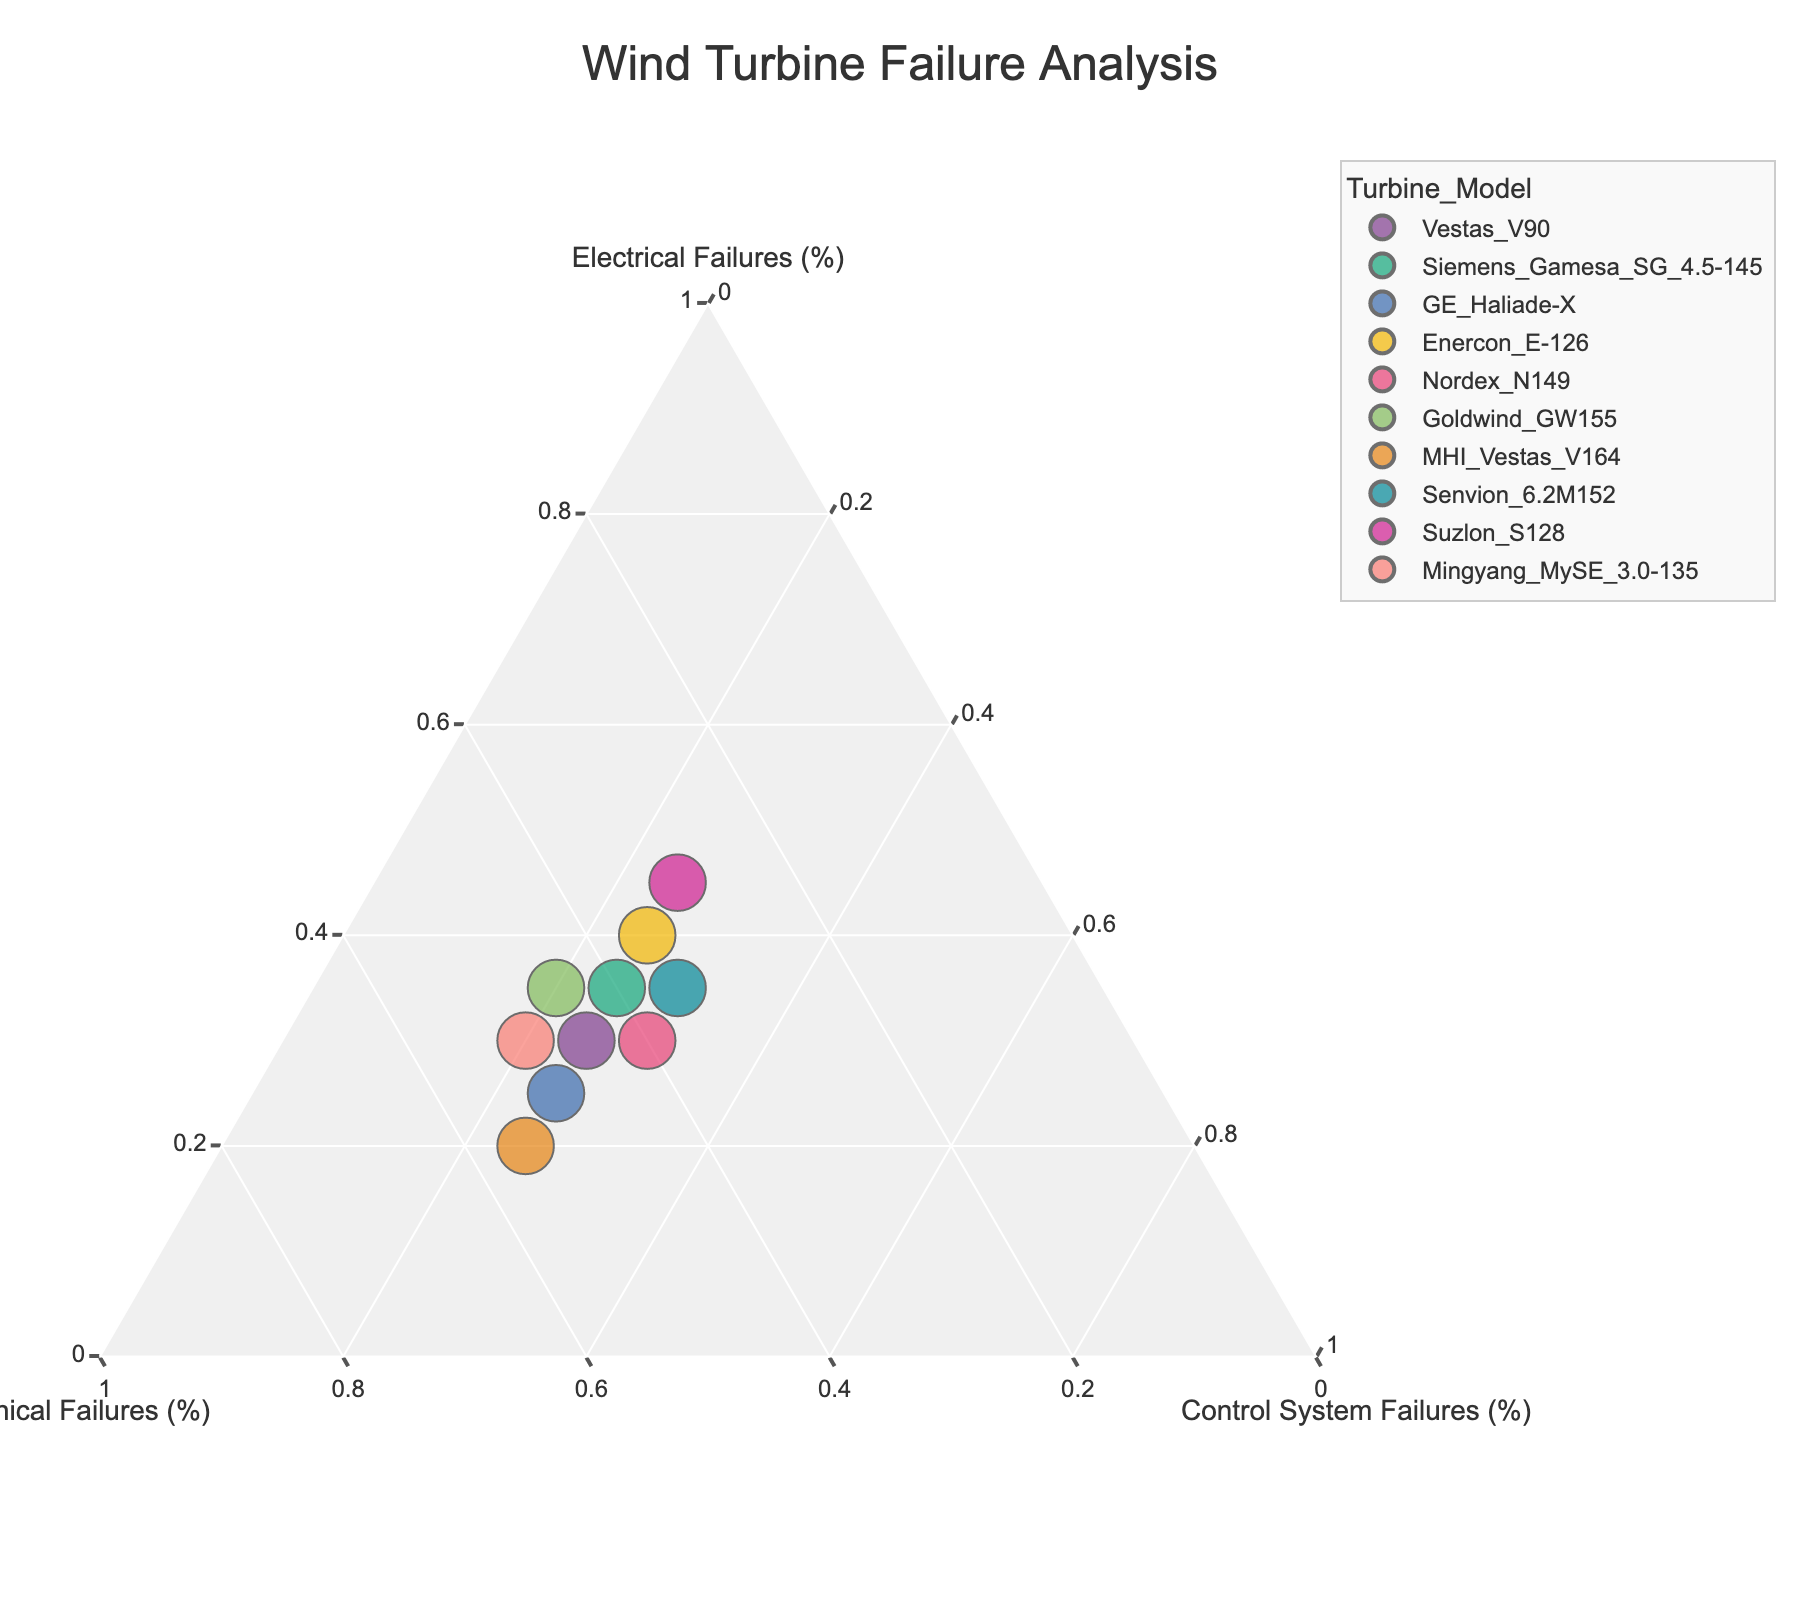What is the title of the chart? The title can be found at the top center of the figure. It is set to provide an overview of the content displayed in the plot.
Answer: Wind Turbine Failure Analysis How many turbine models are analyzed in the plot? The number of unique points representing different turbine models can be determined by counting the distinct markers on the ternary plot. Each marker corresponds to a different turbine model.
Answer: 10 Which turbine model has the highest percentage of electrical failures? By observing the ternary plot, locate the point that is closest to the Electrical Failures (%) axis (i.e., the bottom vertex). The corresponding turbine model will have the highest percentage of electrical failures.
Answer: Suzlon_S128 What is the distribution of failures for the GE Haliade-X turbine? Find the marker associated with the GE Haliade-X turbine and observe its position relative to the three axes. The percentages are given by its relative distance to the vertices for Electrical, Mechanical, and Control System Failures.
Answer: Electrical: 25%, Mechanical: 50%, Control System: 25% Which turbine model has an equal percentage of mechanical and electrical failures? Identify points that lie equidistant from the Mechanical and Electrical axes or fall on the line bisecting the angle between those axes. The hover information can confirm the exact model.
Answer: Senvion_6.2M152 What is the total percentage of failures for the Nordex N149 turbine? The total percentage can be found by adding the contributions from Electrical, Mechanical, and Control System Failures for the Nordex N149 turbine. Observe the relative distances from each axis for this marker.
Answer: 100% How does the failure composition of Vestas V90 compare to Enercon E-126? Locate the markers for both Vestas V90 and Enercon E-126. Compare their positions relative to the three axes, focusing on the proportional contribution of each failure type.
Answer: Vestas V90: Electrical: 30%, Mechanical: 45%, Control System: 25%; Enercon E-126: Electrical: 40%, Mechanical: 35%, Control System: 25% Which turbine model has the highest control system failures? Look for the point closest to the Control System Failures (%) vertex (top vertex) on the ternary plot. The turbine model closest to this will have the highest control system failures.
Answer: Nordex_N149 and Senvion_6.2M152 (tie) What is the mean percentage of mechanical failures among all turbine models? Calculate the average mechanical failure percentage by summing the mechanical failure percentages for all turbine models and dividing by the number of models. (45 + 40 + 50 + 35 + 40 + 45 + 55 + 35 + 30 + 50) / 10 = 425 / 10.
Answer: 42.5% Which turbine model has a balanced failure distribution, with each type of failure close to one-third? Identify the point near the centroid of the ternary diagram, where the percentages of Electrical, Mechanical, and Control System Failures are roughly equal to 33.33%. The hover information can confirm the exact model.
Answer: No turbine model appears to have an exactly balanced failure distribution 